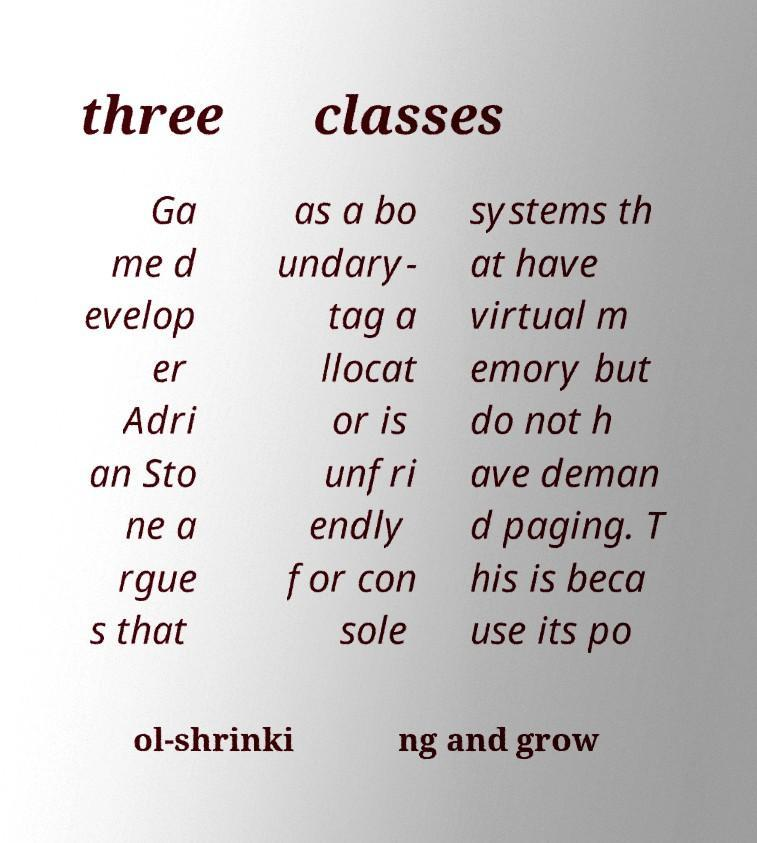Can you accurately transcribe the text from the provided image for me? three classes Ga me d evelop er Adri an Sto ne a rgue s that as a bo undary- tag a llocat or is unfri endly for con sole systems th at have virtual m emory but do not h ave deman d paging. T his is beca use its po ol-shrinki ng and grow 